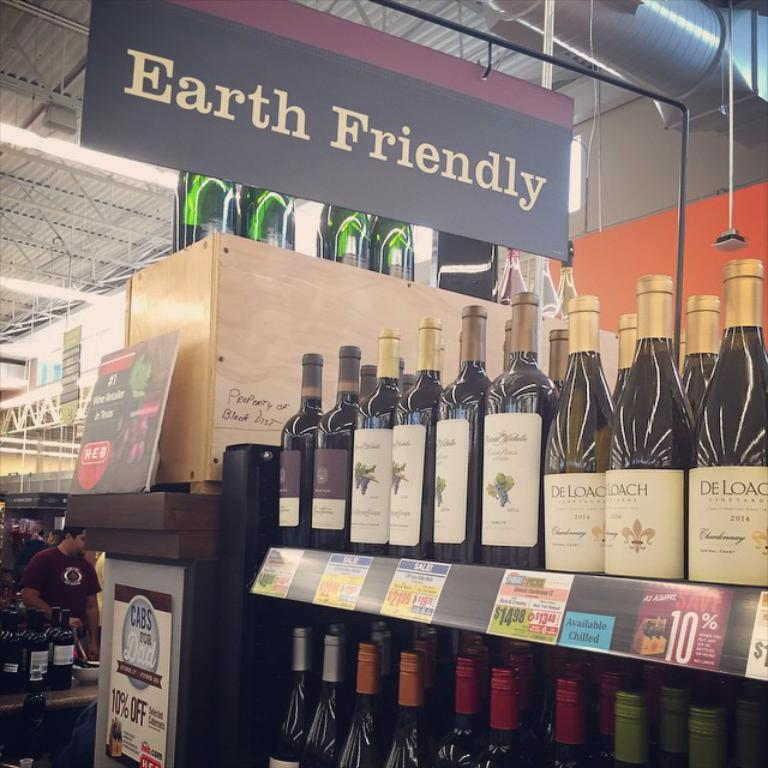<image>
Render a clear and concise summary of the photo. a store disply for bottles of wine under a earth friendly sign 